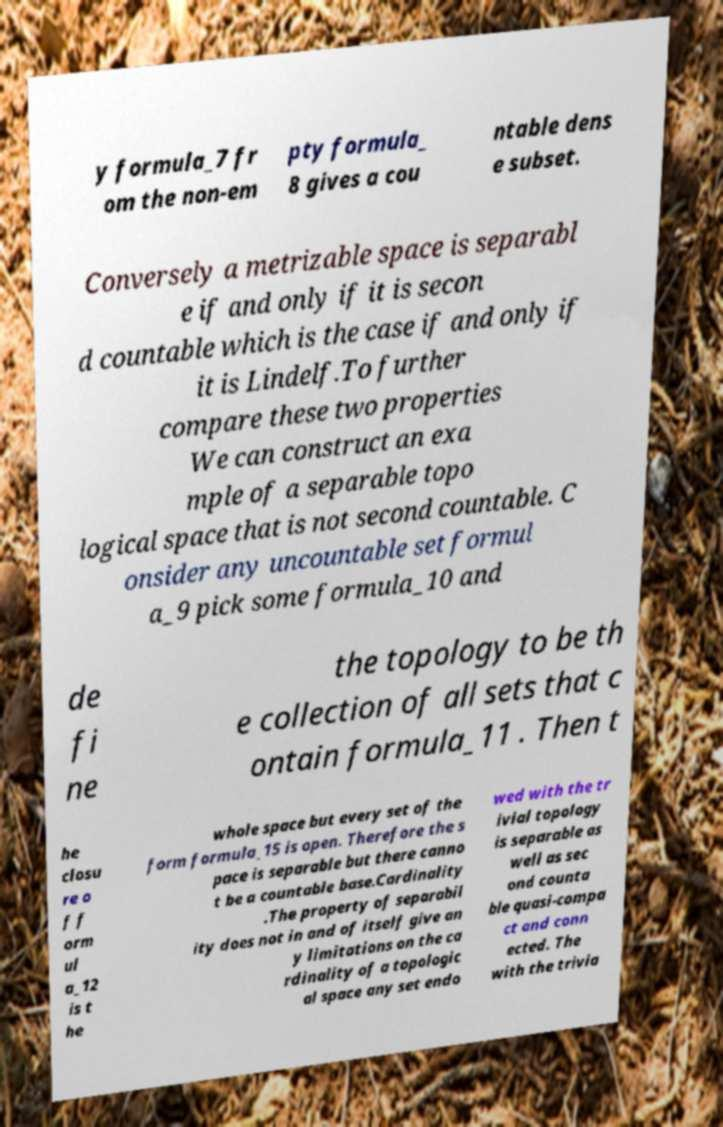There's text embedded in this image that I need extracted. Can you transcribe it verbatim? y formula_7 fr om the non-em pty formula_ 8 gives a cou ntable dens e subset. Conversely a metrizable space is separabl e if and only if it is secon d countable which is the case if and only if it is Lindelf.To further compare these two properties We can construct an exa mple of a separable topo logical space that is not second countable. C onsider any uncountable set formul a_9 pick some formula_10 and de fi ne the topology to be th e collection of all sets that c ontain formula_11 . Then t he closu re o f f orm ul a_12 is t he whole space but every set of the form formula_15 is open. Therefore the s pace is separable but there canno t be a countable base.Cardinality .The property of separabil ity does not in and of itself give an y limitations on the ca rdinality of a topologic al space any set endo wed with the tr ivial topology is separable as well as sec ond counta ble quasi-compa ct and conn ected. The with the trivia 